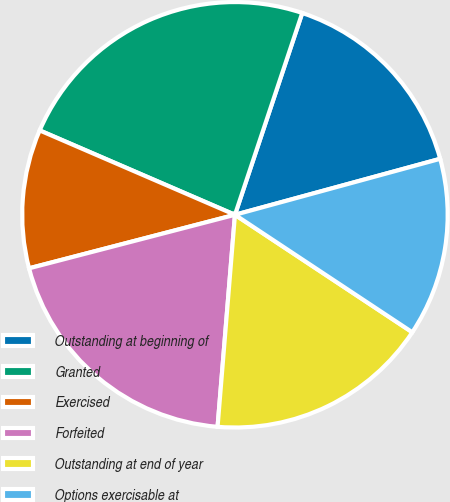Convert chart. <chart><loc_0><loc_0><loc_500><loc_500><pie_chart><fcel>Outstanding at beginning of<fcel>Granted<fcel>Exercised<fcel>Forfeited<fcel>Outstanding at end of year<fcel>Options exercisable at<nl><fcel>15.64%<fcel>23.63%<fcel>10.54%<fcel>19.65%<fcel>16.99%<fcel>13.55%<nl></chart> 